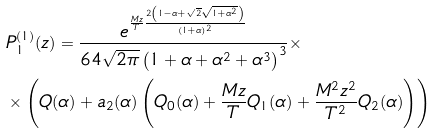Convert formula to latex. <formula><loc_0><loc_0><loc_500><loc_500>& P ^ { ( 1 ) } _ { 1 } ( z ) = \frac { e ^ { \frac { M z } { T } \frac { 2 \left ( 1 - \alpha + \sqrt { 2 } \sqrt { 1 + \alpha ^ { 2 } } \right ) } { ( 1 + \alpha ) ^ { 2 } } } } { 6 4 \sqrt { 2 \pi } \left ( 1 + \alpha + \alpha ^ { 2 } + \alpha ^ { 3 } \right ) ^ { 3 } } \times \\ & \times \left ( Q ( \alpha ) + a _ { 2 } ( \alpha ) \left ( Q _ { 0 } ( \alpha ) + \frac { M z } { T } Q _ { 1 } ( \alpha ) + \frac { M ^ { 2 } z ^ { 2 } } { T ^ { 2 } } Q _ { 2 } ( \alpha ) \right ) \right )</formula> 